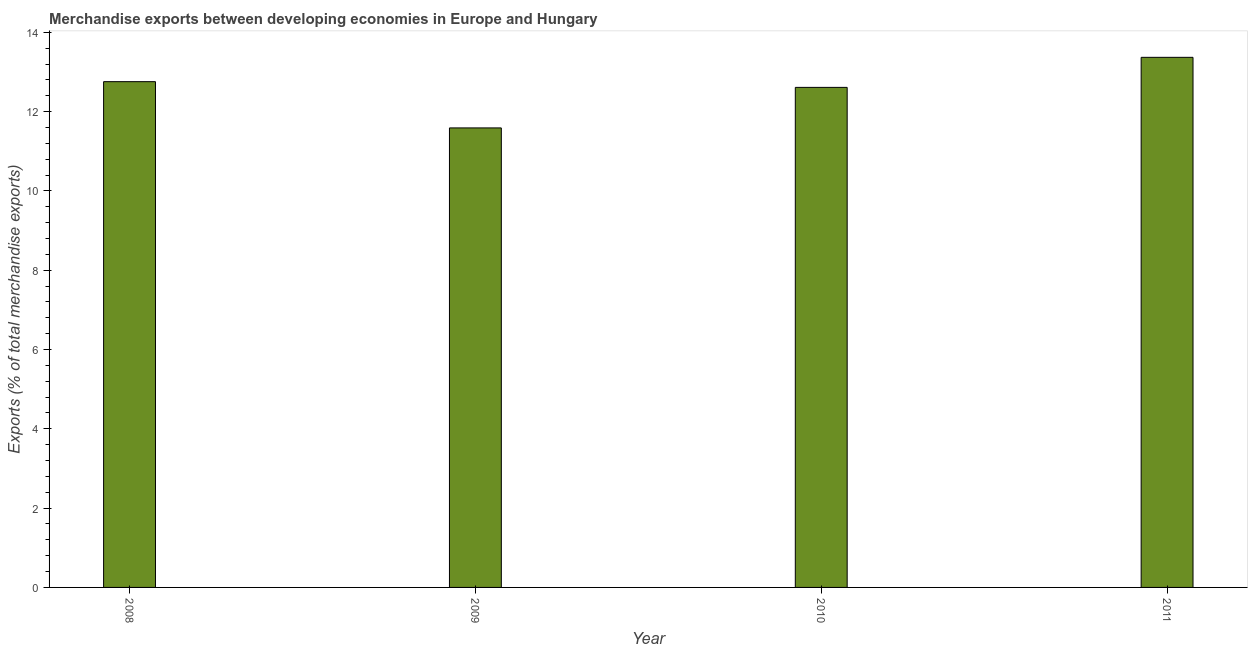What is the title of the graph?
Make the answer very short. Merchandise exports between developing economies in Europe and Hungary. What is the label or title of the Y-axis?
Provide a succinct answer. Exports (% of total merchandise exports). What is the merchandise exports in 2010?
Your response must be concise. 12.61. Across all years, what is the maximum merchandise exports?
Your response must be concise. 13.37. Across all years, what is the minimum merchandise exports?
Provide a short and direct response. 11.59. In which year was the merchandise exports maximum?
Make the answer very short. 2011. What is the sum of the merchandise exports?
Keep it short and to the point. 50.32. What is the difference between the merchandise exports in 2010 and 2011?
Offer a very short reply. -0.76. What is the average merchandise exports per year?
Make the answer very short. 12.58. What is the median merchandise exports?
Ensure brevity in your answer.  12.68. In how many years, is the merchandise exports greater than 5.2 %?
Make the answer very short. 4. What is the ratio of the merchandise exports in 2009 to that in 2010?
Offer a terse response. 0.92. Is the difference between the merchandise exports in 2009 and 2010 greater than the difference between any two years?
Keep it short and to the point. No. What is the difference between the highest and the second highest merchandise exports?
Keep it short and to the point. 0.61. What is the difference between the highest and the lowest merchandise exports?
Your answer should be compact. 1.78. Are all the bars in the graph horizontal?
Your response must be concise. No. How many years are there in the graph?
Offer a terse response. 4. Are the values on the major ticks of Y-axis written in scientific E-notation?
Your answer should be very brief. No. What is the Exports (% of total merchandise exports) of 2008?
Provide a succinct answer. 12.75. What is the Exports (% of total merchandise exports) in 2009?
Ensure brevity in your answer.  11.59. What is the Exports (% of total merchandise exports) of 2010?
Offer a terse response. 12.61. What is the Exports (% of total merchandise exports) in 2011?
Your answer should be very brief. 13.37. What is the difference between the Exports (% of total merchandise exports) in 2008 and 2009?
Provide a short and direct response. 1.17. What is the difference between the Exports (% of total merchandise exports) in 2008 and 2010?
Make the answer very short. 0.14. What is the difference between the Exports (% of total merchandise exports) in 2008 and 2011?
Offer a very short reply. -0.61. What is the difference between the Exports (% of total merchandise exports) in 2009 and 2010?
Make the answer very short. -1.02. What is the difference between the Exports (% of total merchandise exports) in 2009 and 2011?
Keep it short and to the point. -1.78. What is the difference between the Exports (% of total merchandise exports) in 2010 and 2011?
Offer a terse response. -0.76. What is the ratio of the Exports (% of total merchandise exports) in 2008 to that in 2009?
Ensure brevity in your answer.  1.1. What is the ratio of the Exports (% of total merchandise exports) in 2008 to that in 2011?
Provide a short and direct response. 0.95. What is the ratio of the Exports (% of total merchandise exports) in 2009 to that in 2010?
Ensure brevity in your answer.  0.92. What is the ratio of the Exports (% of total merchandise exports) in 2009 to that in 2011?
Offer a terse response. 0.87. What is the ratio of the Exports (% of total merchandise exports) in 2010 to that in 2011?
Offer a very short reply. 0.94. 